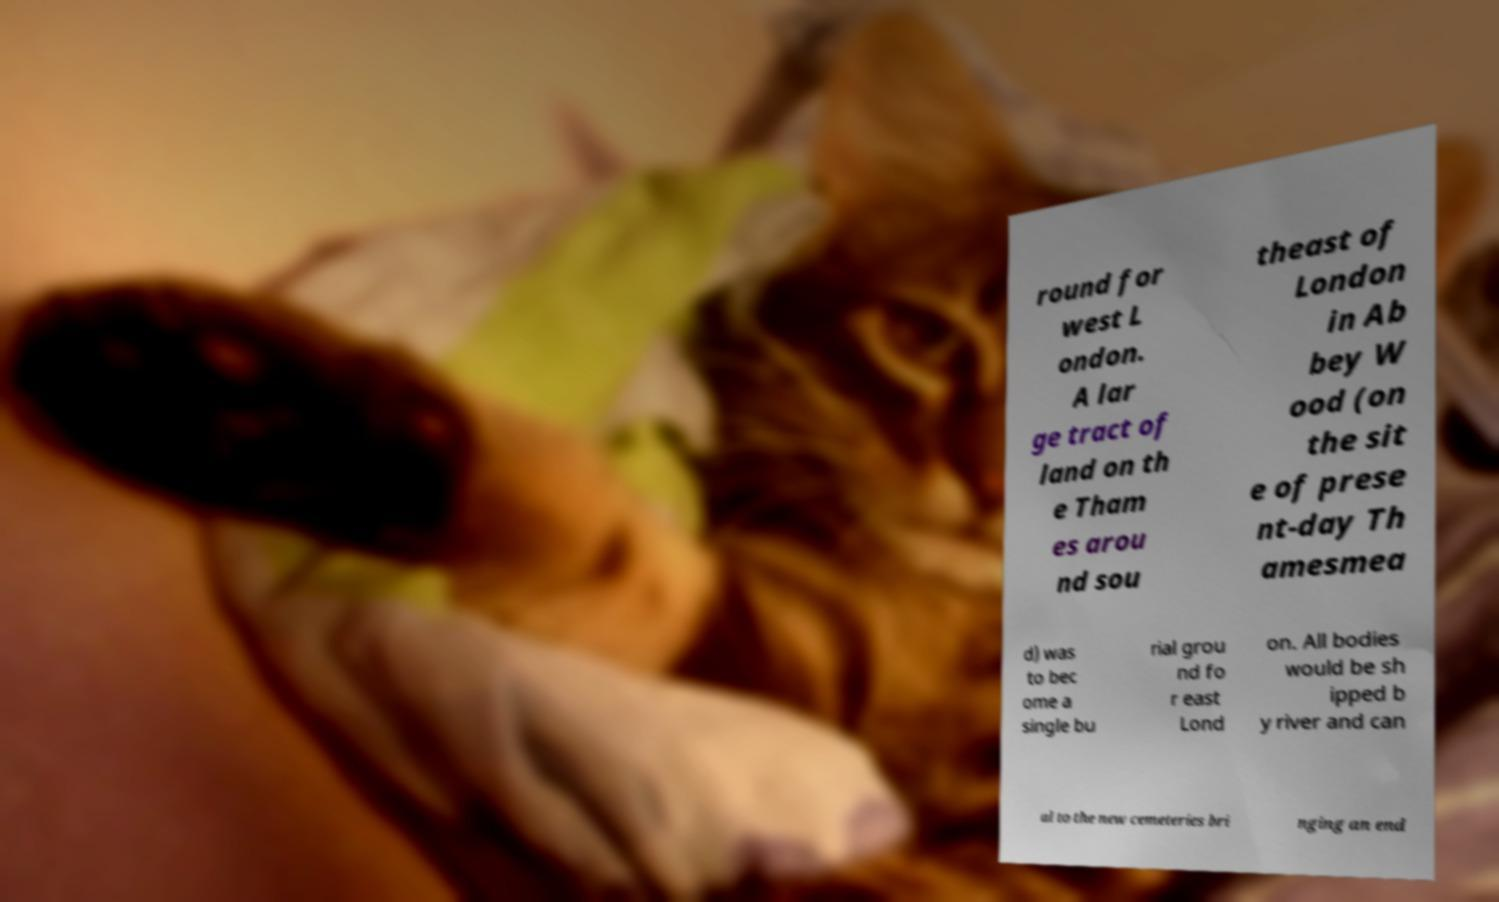Please read and relay the text visible in this image. What does it say? round for west L ondon. A lar ge tract of land on th e Tham es arou nd sou theast of London in Ab bey W ood (on the sit e of prese nt-day Th amesmea d) was to bec ome a single bu rial grou nd fo r east Lond on. All bodies would be sh ipped b y river and can al to the new cemeteries bri nging an end 